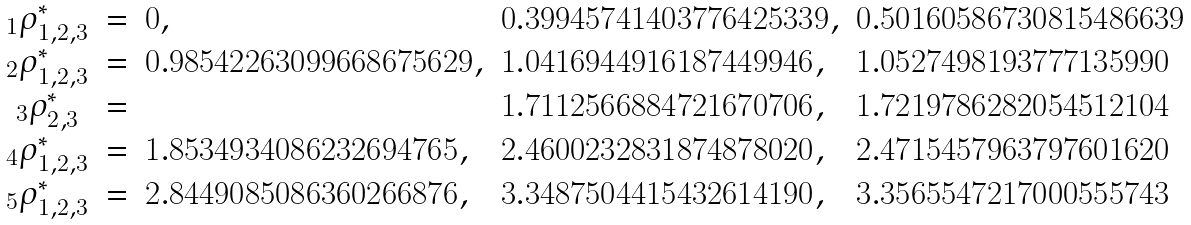<formula> <loc_0><loc_0><loc_500><loc_500>\begin{array} { c c l l l } { _ { 1 } } \rho ^ { * } _ { 1 , 2 , 3 } & = & 0 , & 0 . 3 9 9 4 5 7 4 1 4 0 3 7 7 6 4 2 5 3 3 9 , & 0 . 5 0 1 6 0 5 8 6 7 3 0 8 1 5 4 8 6 6 3 9 \\ { _ { 2 } } \rho ^ { * } _ { 1 , 2 , 3 } & = & 0 . 9 8 5 4 2 2 6 3 0 9 9 6 6 8 6 7 5 6 2 9 , & 1 . 0 4 1 6 9 4 4 9 1 6 1 8 7 4 4 9 9 4 6 , & 1 . 0 5 2 7 4 9 8 1 9 3 7 7 7 1 3 5 9 9 0 \\ { _ { 3 } } \rho ^ { * } _ { 2 , 3 } & = & & 1 . 7 1 1 2 5 6 6 8 8 4 7 2 1 6 7 0 7 0 6 , & 1 . 7 2 1 9 7 8 6 2 8 2 0 5 4 5 1 2 1 0 4 \\ { _ { 4 } } \rho ^ { * } _ { 1 , 2 , 3 } & = & 1 . 8 5 3 4 9 3 4 0 8 6 2 3 2 6 9 4 7 6 5 , & 2 . 4 6 0 0 2 3 2 8 3 1 8 7 4 8 7 8 0 2 0 , & 2 . 4 7 1 5 4 5 7 9 6 3 7 9 7 6 0 1 6 2 0 \\ { _ { 5 } } \rho ^ { * } _ { 1 , 2 , 3 } & = & 2 . 8 4 4 9 0 8 5 0 8 6 3 6 0 2 6 6 8 7 6 , & 3 . 3 4 8 7 5 0 4 4 1 5 4 3 2 6 1 4 1 9 0 , & 3 . 3 5 6 5 5 4 7 2 1 7 0 0 0 5 5 5 7 4 3 \\ \end{array}</formula> 